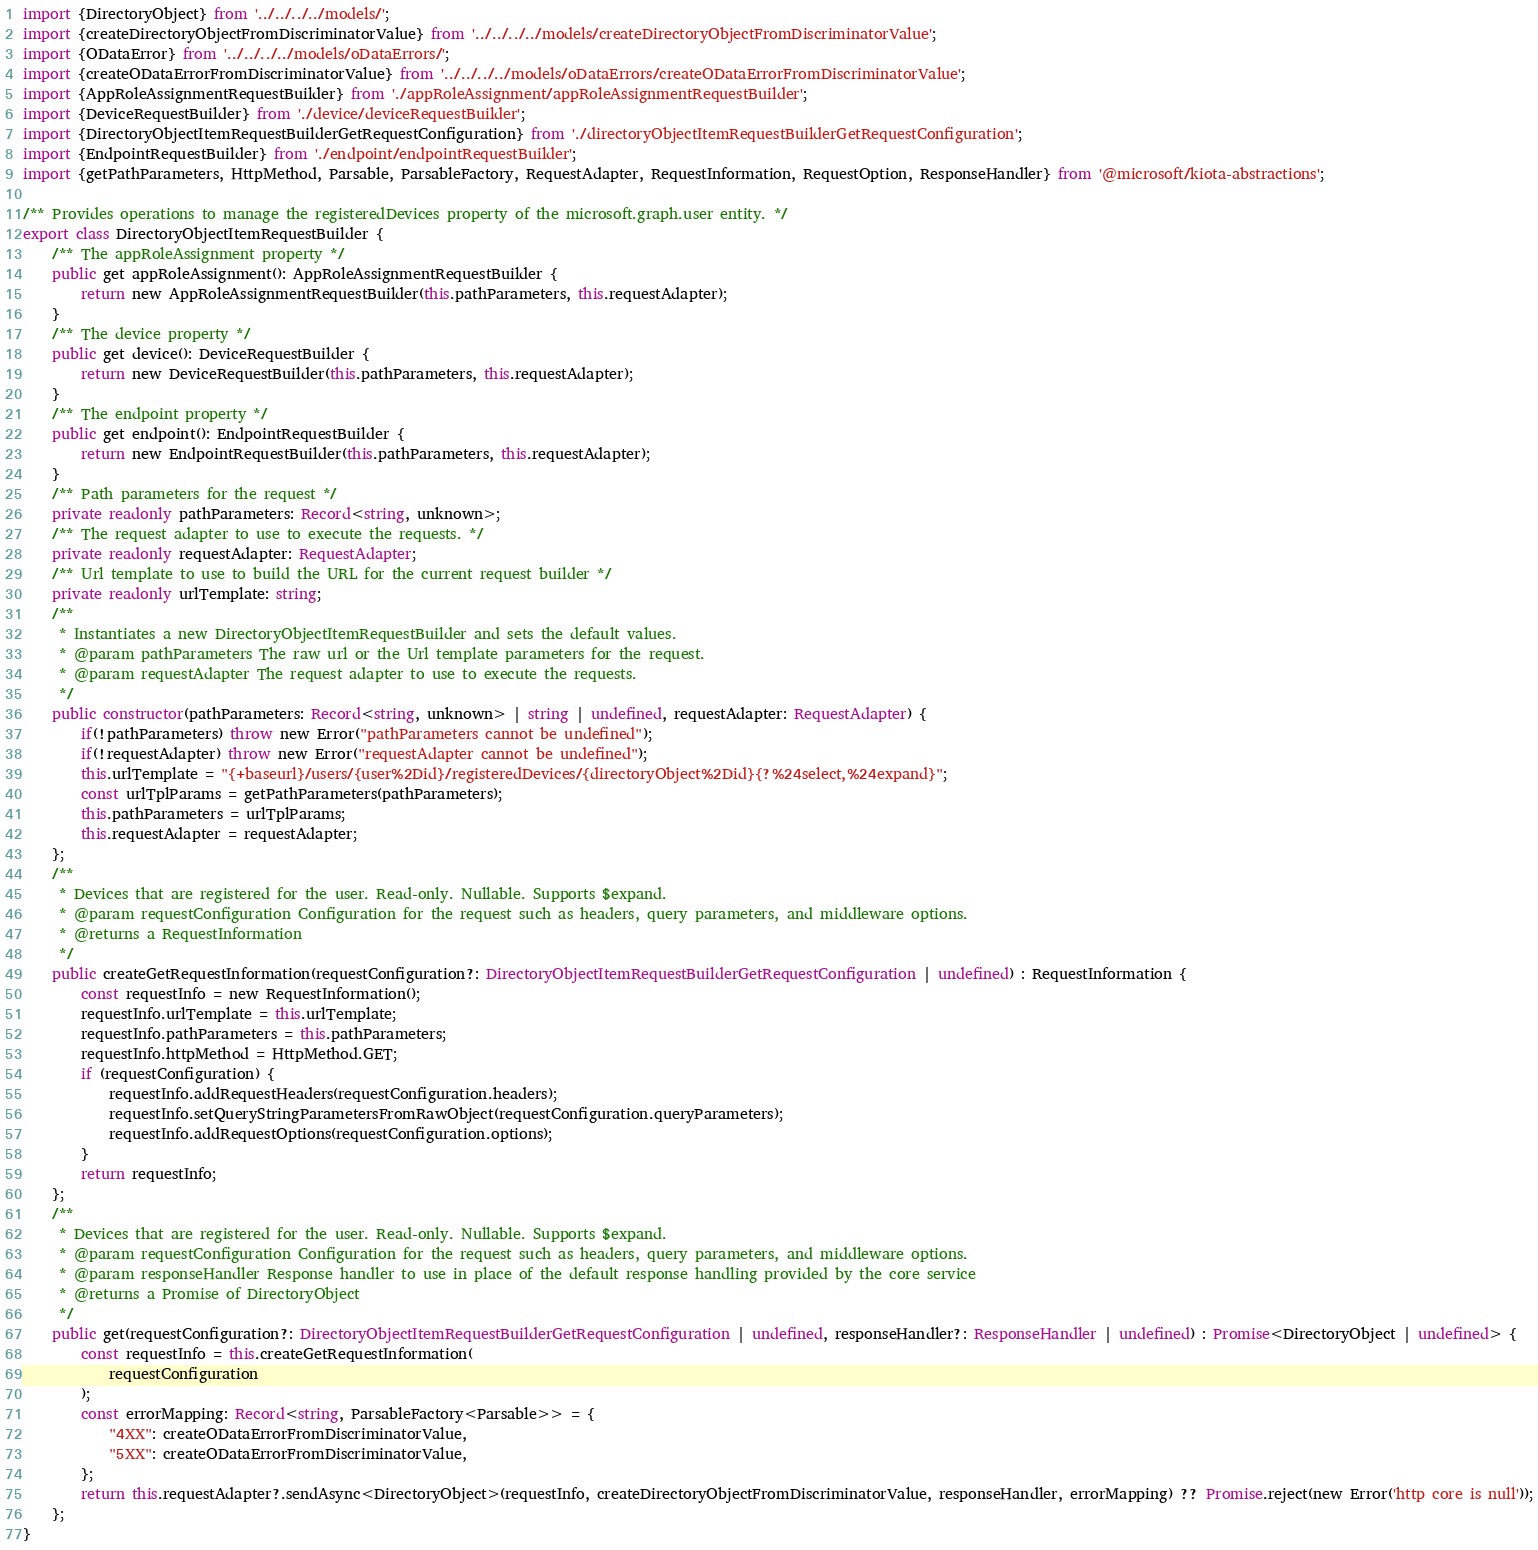Convert code to text. <code><loc_0><loc_0><loc_500><loc_500><_TypeScript_>import {DirectoryObject} from '../../../../models/';
import {createDirectoryObjectFromDiscriminatorValue} from '../../../../models/createDirectoryObjectFromDiscriminatorValue';
import {ODataError} from '../../../../models/oDataErrors/';
import {createODataErrorFromDiscriminatorValue} from '../../../../models/oDataErrors/createODataErrorFromDiscriminatorValue';
import {AppRoleAssignmentRequestBuilder} from './appRoleAssignment/appRoleAssignmentRequestBuilder';
import {DeviceRequestBuilder} from './device/deviceRequestBuilder';
import {DirectoryObjectItemRequestBuilderGetRequestConfiguration} from './directoryObjectItemRequestBuilderGetRequestConfiguration';
import {EndpointRequestBuilder} from './endpoint/endpointRequestBuilder';
import {getPathParameters, HttpMethod, Parsable, ParsableFactory, RequestAdapter, RequestInformation, RequestOption, ResponseHandler} from '@microsoft/kiota-abstractions';

/** Provides operations to manage the registeredDevices property of the microsoft.graph.user entity. */
export class DirectoryObjectItemRequestBuilder {
    /** The appRoleAssignment property */
    public get appRoleAssignment(): AppRoleAssignmentRequestBuilder {
        return new AppRoleAssignmentRequestBuilder(this.pathParameters, this.requestAdapter);
    }
    /** The device property */
    public get device(): DeviceRequestBuilder {
        return new DeviceRequestBuilder(this.pathParameters, this.requestAdapter);
    }
    /** The endpoint property */
    public get endpoint(): EndpointRequestBuilder {
        return new EndpointRequestBuilder(this.pathParameters, this.requestAdapter);
    }
    /** Path parameters for the request */
    private readonly pathParameters: Record<string, unknown>;
    /** The request adapter to use to execute the requests. */
    private readonly requestAdapter: RequestAdapter;
    /** Url template to use to build the URL for the current request builder */
    private readonly urlTemplate: string;
    /**
     * Instantiates a new DirectoryObjectItemRequestBuilder and sets the default values.
     * @param pathParameters The raw url or the Url template parameters for the request.
     * @param requestAdapter The request adapter to use to execute the requests.
     */
    public constructor(pathParameters: Record<string, unknown> | string | undefined, requestAdapter: RequestAdapter) {
        if(!pathParameters) throw new Error("pathParameters cannot be undefined");
        if(!requestAdapter) throw new Error("requestAdapter cannot be undefined");
        this.urlTemplate = "{+baseurl}/users/{user%2Did}/registeredDevices/{directoryObject%2Did}{?%24select,%24expand}";
        const urlTplParams = getPathParameters(pathParameters);
        this.pathParameters = urlTplParams;
        this.requestAdapter = requestAdapter;
    };
    /**
     * Devices that are registered for the user. Read-only. Nullable. Supports $expand.
     * @param requestConfiguration Configuration for the request such as headers, query parameters, and middleware options.
     * @returns a RequestInformation
     */
    public createGetRequestInformation(requestConfiguration?: DirectoryObjectItemRequestBuilderGetRequestConfiguration | undefined) : RequestInformation {
        const requestInfo = new RequestInformation();
        requestInfo.urlTemplate = this.urlTemplate;
        requestInfo.pathParameters = this.pathParameters;
        requestInfo.httpMethod = HttpMethod.GET;
        if (requestConfiguration) {
            requestInfo.addRequestHeaders(requestConfiguration.headers);
            requestInfo.setQueryStringParametersFromRawObject(requestConfiguration.queryParameters);
            requestInfo.addRequestOptions(requestConfiguration.options);
        }
        return requestInfo;
    };
    /**
     * Devices that are registered for the user. Read-only. Nullable. Supports $expand.
     * @param requestConfiguration Configuration for the request such as headers, query parameters, and middleware options.
     * @param responseHandler Response handler to use in place of the default response handling provided by the core service
     * @returns a Promise of DirectoryObject
     */
    public get(requestConfiguration?: DirectoryObjectItemRequestBuilderGetRequestConfiguration | undefined, responseHandler?: ResponseHandler | undefined) : Promise<DirectoryObject | undefined> {
        const requestInfo = this.createGetRequestInformation(
            requestConfiguration
        );
        const errorMapping: Record<string, ParsableFactory<Parsable>> = {
            "4XX": createODataErrorFromDiscriminatorValue,
            "5XX": createODataErrorFromDiscriminatorValue,
        };
        return this.requestAdapter?.sendAsync<DirectoryObject>(requestInfo, createDirectoryObjectFromDiscriminatorValue, responseHandler, errorMapping) ?? Promise.reject(new Error('http core is null'));
    };
}
</code> 